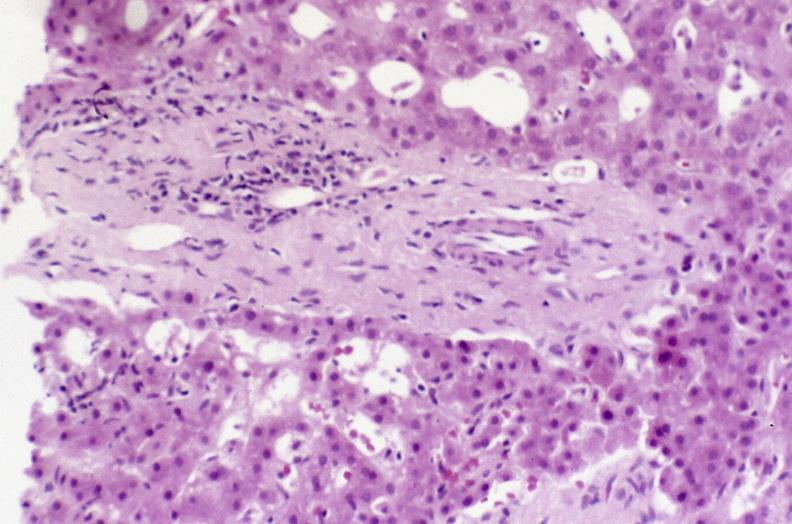s lymphoma present?
Answer the question using a single word or phrase. No 